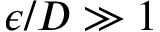Convert formula to latex. <formula><loc_0><loc_0><loc_500><loc_500>\epsilon / D \gg 1</formula> 